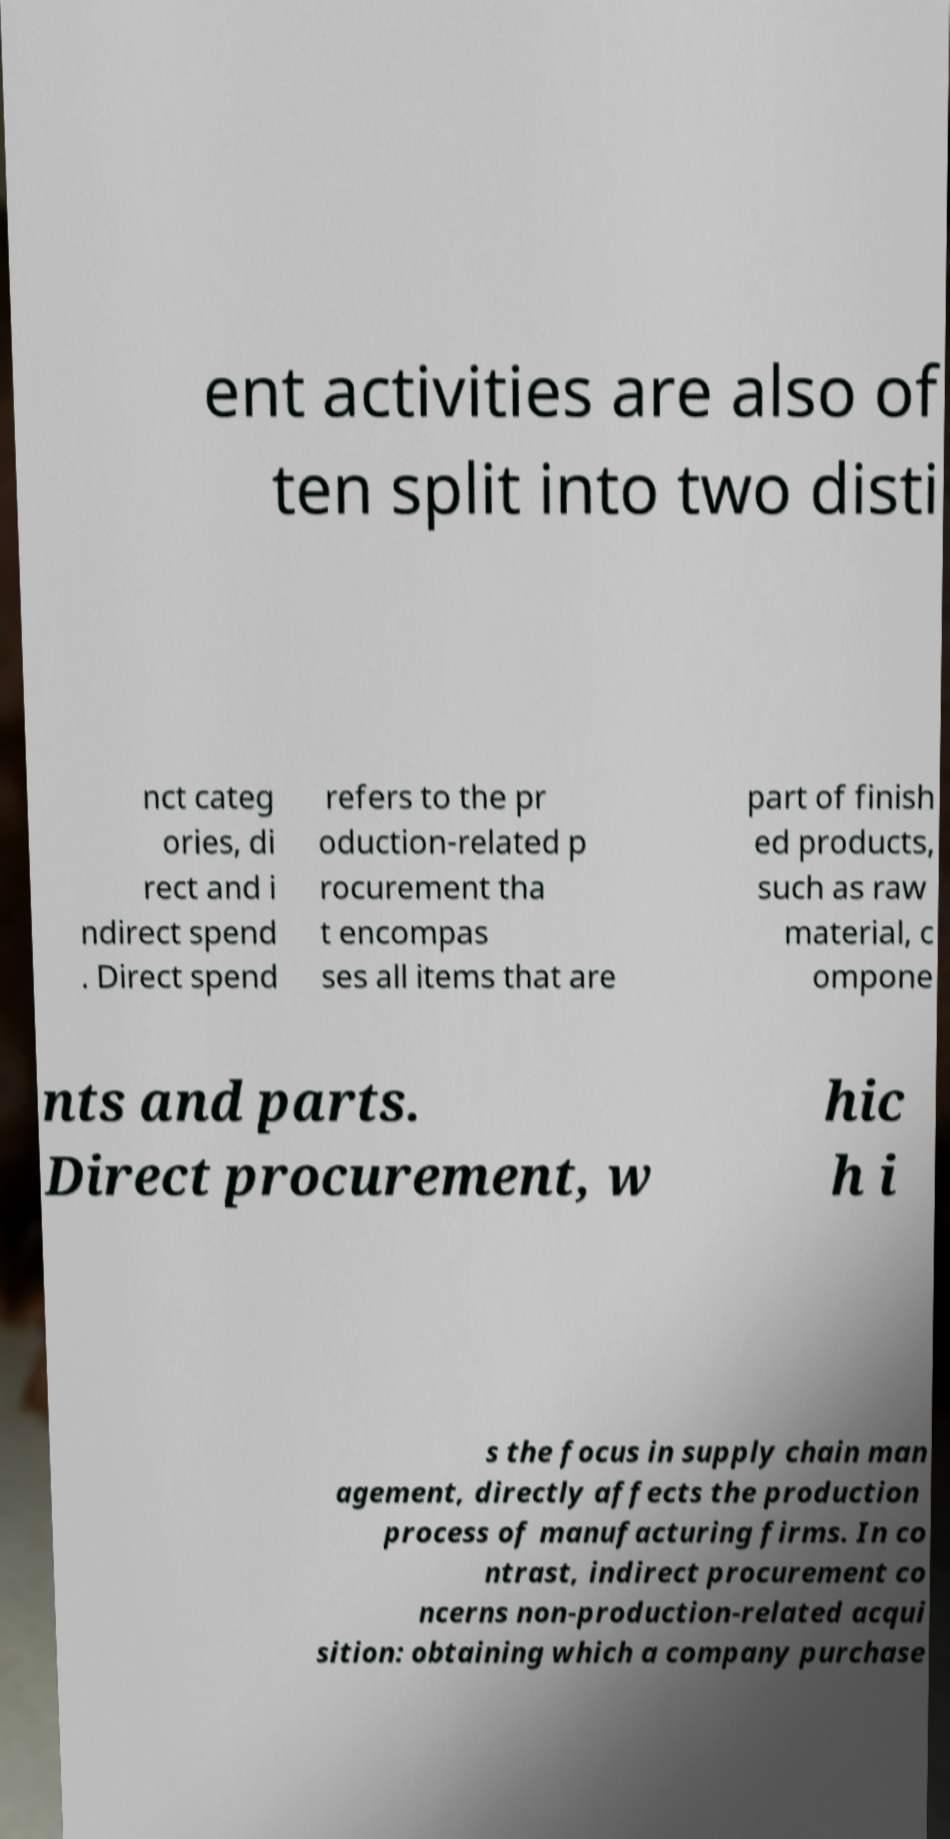There's text embedded in this image that I need extracted. Can you transcribe it verbatim? ent activities are also of ten split into two disti nct categ ories, di rect and i ndirect spend . Direct spend refers to the pr oduction-related p rocurement tha t encompas ses all items that are part of finish ed products, such as raw material, c ompone nts and parts. Direct procurement, w hic h i s the focus in supply chain man agement, directly affects the production process of manufacturing firms. In co ntrast, indirect procurement co ncerns non-production-related acqui sition: obtaining which a company purchase 